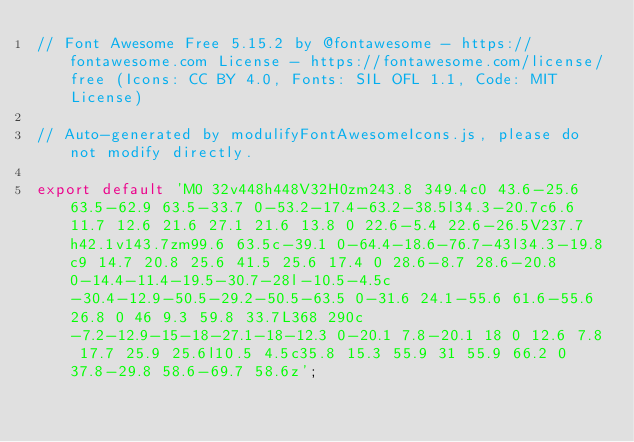Convert code to text. <code><loc_0><loc_0><loc_500><loc_500><_JavaScript_>// Font Awesome Free 5.15.2 by @fontawesome - https://fontawesome.com License - https://fontawesome.com/license/free (Icons: CC BY 4.0, Fonts: SIL OFL 1.1, Code: MIT License)

// Auto-generated by modulifyFontAwesomeIcons.js, please do not modify directly.

export default 'M0 32v448h448V32H0zm243.8 349.4c0 43.6-25.6 63.5-62.9 63.5-33.7 0-53.2-17.4-63.2-38.5l34.3-20.7c6.6 11.7 12.6 21.6 27.1 21.6 13.8 0 22.6-5.4 22.6-26.5V237.7h42.1v143.7zm99.6 63.5c-39.1 0-64.4-18.6-76.7-43l34.3-19.8c9 14.7 20.8 25.6 41.5 25.6 17.4 0 28.6-8.7 28.6-20.8 0-14.4-11.4-19.5-30.7-28l-10.5-4.5c-30.4-12.9-50.5-29.2-50.5-63.5 0-31.6 24.1-55.6 61.6-55.6 26.8 0 46 9.3 59.8 33.7L368 290c-7.2-12.9-15-18-27.1-18-12.3 0-20.1 7.8-20.1 18 0 12.6 7.8 17.7 25.9 25.6l10.5 4.5c35.8 15.3 55.9 31 55.9 66.2 0 37.8-29.8 58.6-69.7 58.6z';</code> 